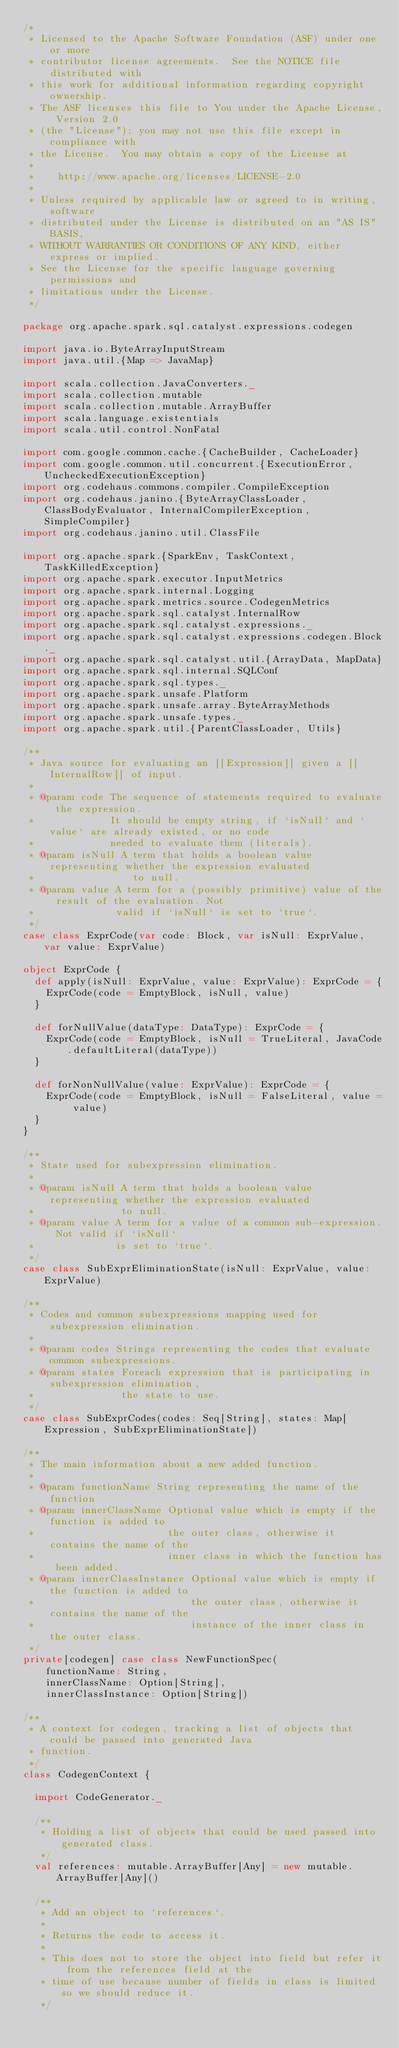Convert code to text. <code><loc_0><loc_0><loc_500><loc_500><_Scala_>/*
 * Licensed to the Apache Software Foundation (ASF) under one or more
 * contributor license agreements.  See the NOTICE file distributed with
 * this work for additional information regarding copyright ownership.
 * The ASF licenses this file to You under the Apache License, Version 2.0
 * (the "License"); you may not use this file except in compliance with
 * the License.  You may obtain a copy of the License at
 *
 *    http://www.apache.org/licenses/LICENSE-2.0
 *
 * Unless required by applicable law or agreed to in writing, software
 * distributed under the License is distributed on an "AS IS" BASIS,
 * WITHOUT WARRANTIES OR CONDITIONS OF ANY KIND, either express or implied.
 * See the License for the specific language governing permissions and
 * limitations under the License.
 */

package org.apache.spark.sql.catalyst.expressions.codegen

import java.io.ByteArrayInputStream
import java.util.{Map => JavaMap}

import scala.collection.JavaConverters._
import scala.collection.mutable
import scala.collection.mutable.ArrayBuffer
import scala.language.existentials
import scala.util.control.NonFatal

import com.google.common.cache.{CacheBuilder, CacheLoader}
import com.google.common.util.concurrent.{ExecutionError, UncheckedExecutionException}
import org.codehaus.commons.compiler.CompileException
import org.codehaus.janino.{ByteArrayClassLoader, ClassBodyEvaluator, InternalCompilerException, SimpleCompiler}
import org.codehaus.janino.util.ClassFile

import org.apache.spark.{SparkEnv, TaskContext, TaskKilledException}
import org.apache.spark.executor.InputMetrics
import org.apache.spark.internal.Logging
import org.apache.spark.metrics.source.CodegenMetrics
import org.apache.spark.sql.catalyst.InternalRow
import org.apache.spark.sql.catalyst.expressions._
import org.apache.spark.sql.catalyst.expressions.codegen.Block._
import org.apache.spark.sql.catalyst.util.{ArrayData, MapData}
import org.apache.spark.sql.internal.SQLConf
import org.apache.spark.sql.types._
import org.apache.spark.unsafe.Platform
import org.apache.spark.unsafe.array.ByteArrayMethods
import org.apache.spark.unsafe.types._
import org.apache.spark.util.{ParentClassLoader, Utils}

/**
 * Java source for evaluating an [[Expression]] given a [[InternalRow]] of input.
 *
 * @param code The sequence of statements required to evaluate the expression.
 *             It should be empty string, if `isNull` and `value` are already existed, or no code
 *             needed to evaluate them (literals).
 * @param isNull A term that holds a boolean value representing whether the expression evaluated
 *                 to null.
 * @param value A term for a (possibly primitive) value of the result of the evaluation. Not
 *              valid if `isNull` is set to `true`.
 */
case class ExprCode(var code: Block, var isNull: ExprValue, var value: ExprValue)

object ExprCode {
  def apply(isNull: ExprValue, value: ExprValue): ExprCode = {
    ExprCode(code = EmptyBlock, isNull, value)
  }

  def forNullValue(dataType: DataType): ExprCode = {
    ExprCode(code = EmptyBlock, isNull = TrueLiteral, JavaCode.defaultLiteral(dataType))
  }

  def forNonNullValue(value: ExprValue): ExprCode = {
    ExprCode(code = EmptyBlock, isNull = FalseLiteral, value = value)
  }
}

/**
 * State used for subexpression elimination.
 *
 * @param isNull A term that holds a boolean value representing whether the expression evaluated
 *               to null.
 * @param value A term for a value of a common sub-expression. Not valid if `isNull`
 *              is set to `true`.
 */
case class SubExprEliminationState(isNull: ExprValue, value: ExprValue)

/**
 * Codes and common subexpressions mapping used for subexpression elimination.
 *
 * @param codes Strings representing the codes that evaluate common subexpressions.
 * @param states Foreach expression that is participating in subexpression elimination,
 *               the state to use.
 */
case class SubExprCodes(codes: Seq[String], states: Map[Expression, SubExprEliminationState])

/**
 * The main information about a new added function.
 *
 * @param functionName String representing the name of the function
 * @param innerClassName Optional value which is empty if the function is added to
 *                       the outer class, otherwise it contains the name of the
 *                       inner class in which the function has been added.
 * @param innerClassInstance Optional value which is empty if the function is added to
 *                           the outer class, otherwise it contains the name of the
 *                           instance of the inner class in the outer class.
 */
private[codegen] case class NewFunctionSpec(
    functionName: String,
    innerClassName: Option[String],
    innerClassInstance: Option[String])

/**
 * A context for codegen, tracking a list of objects that could be passed into generated Java
 * function.
 */
class CodegenContext {

  import CodeGenerator._

  /**
   * Holding a list of objects that could be used passed into generated class.
   */
  val references: mutable.ArrayBuffer[Any] = new mutable.ArrayBuffer[Any]()

  /**
   * Add an object to `references`.
   *
   * Returns the code to access it.
   *
   * This does not to store the object into field but refer it from the references field at the
   * time of use because number of fields in class is limited so we should reduce it.
   */</code> 